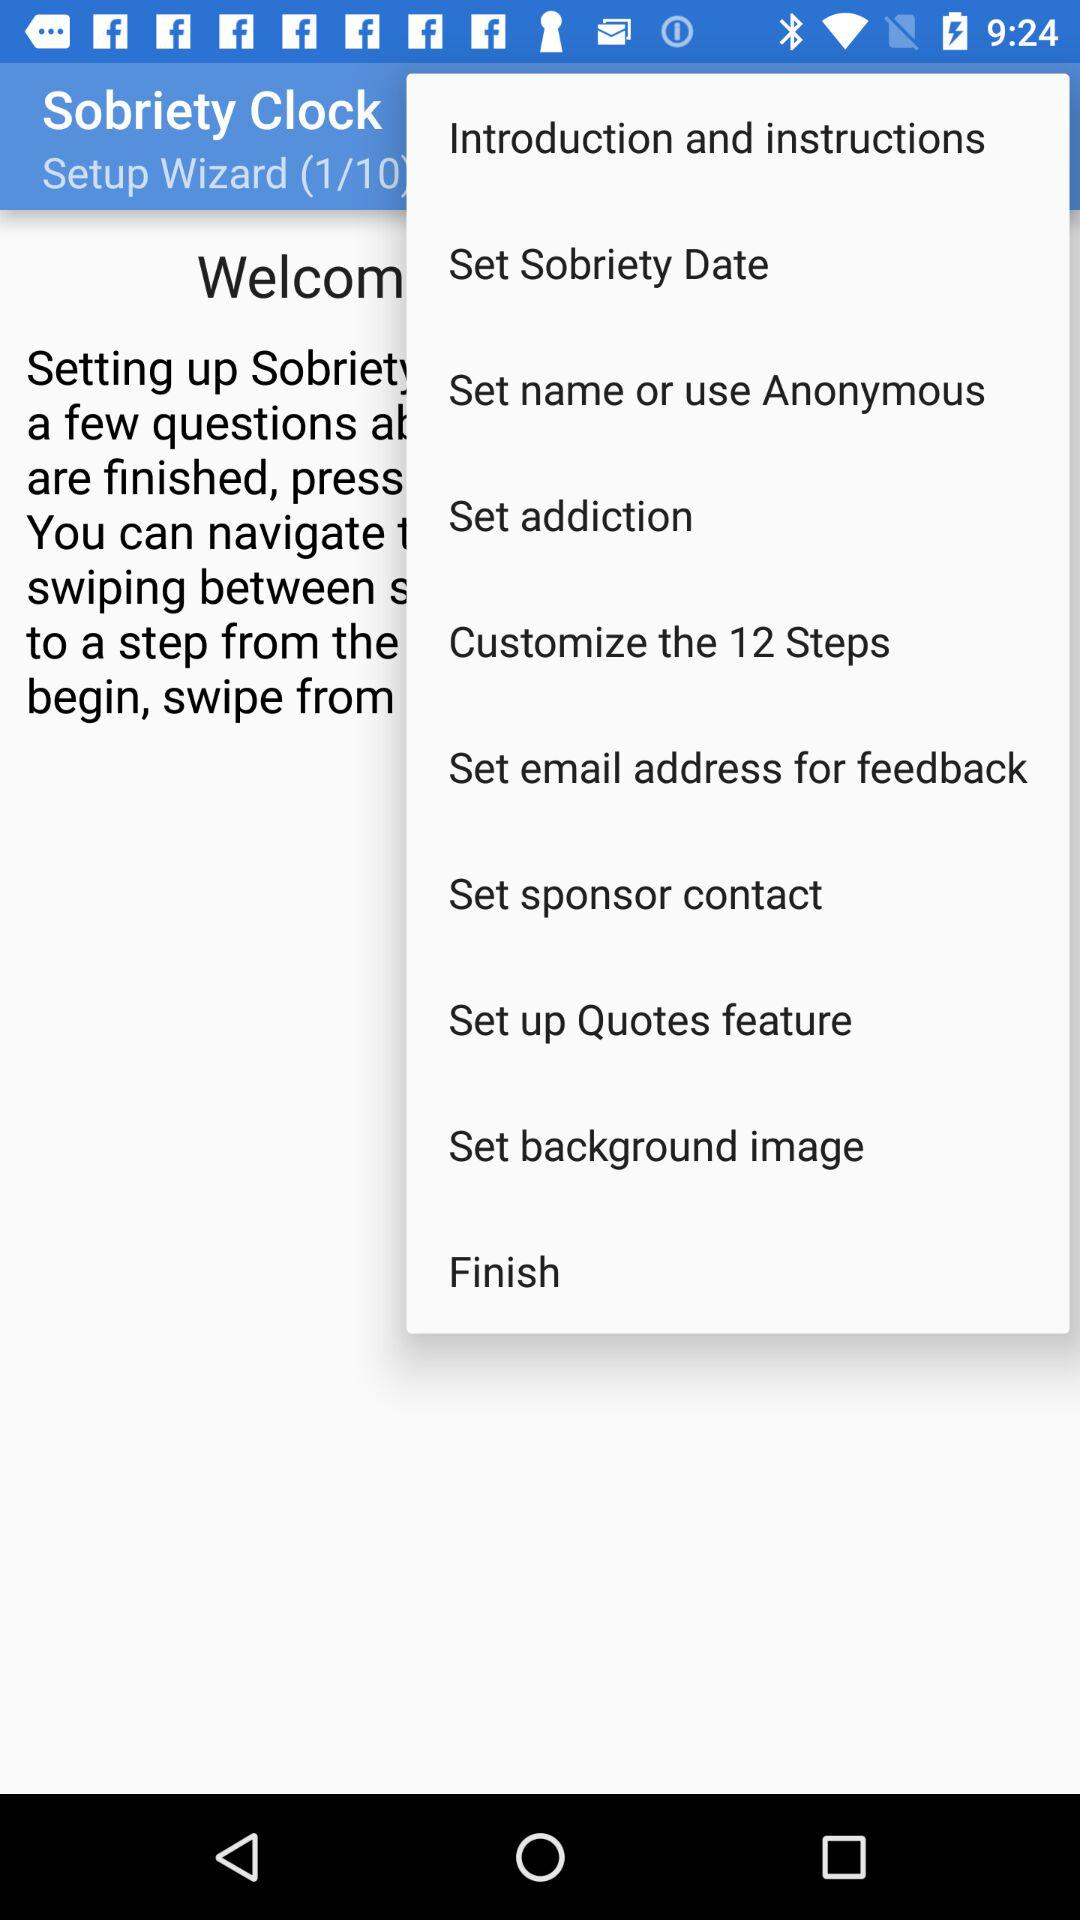How many total pages are in the "Setup Wizard"? There are 10 pages. 